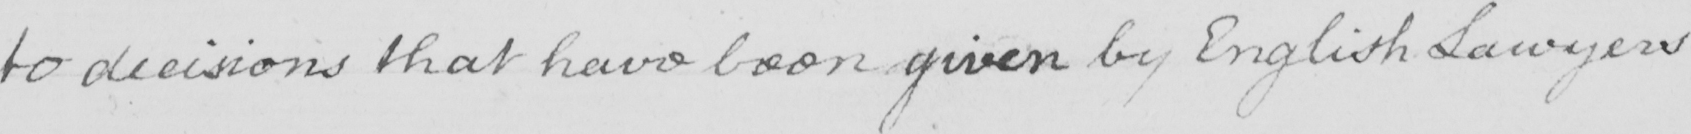Can you tell me what this handwritten text says? to decisions that have been given by English Lawyers 